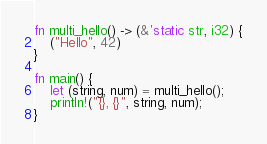Convert code to text. <code><loc_0><loc_0><loc_500><loc_500><_Rust_>fn multi_hello() -> (&'static str, i32) {
    ("Hello", 42)
}

fn main() {
    let (string, num) = multi_hello();
    println!("{}, {}", string, num);
}
</code> 